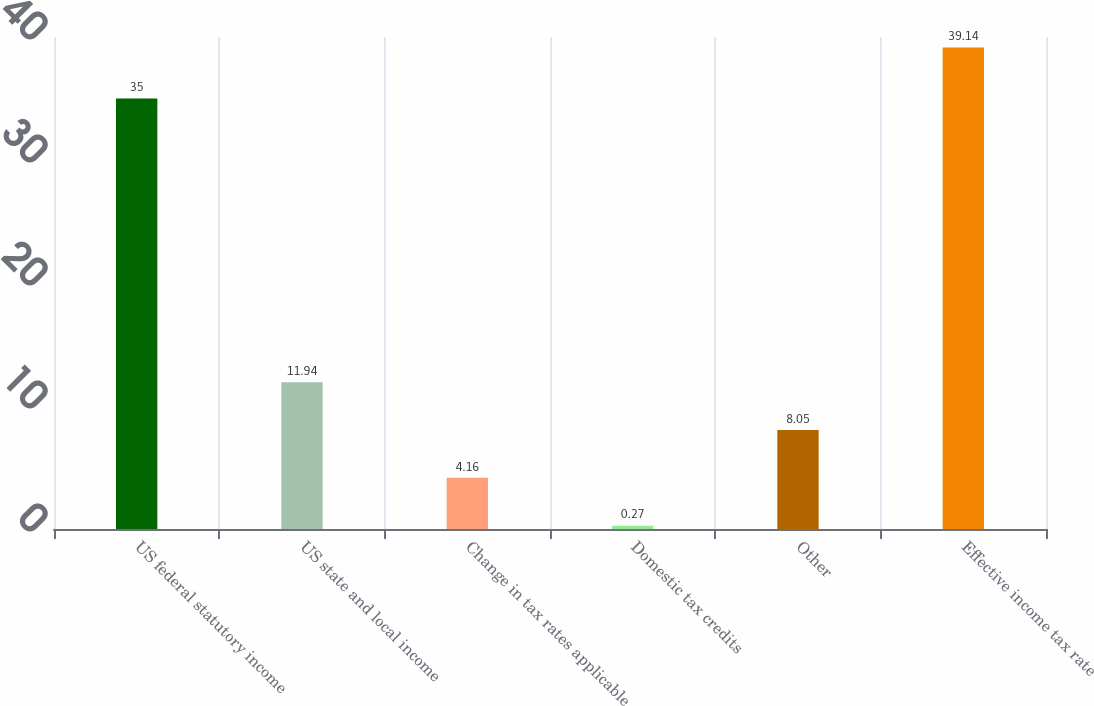<chart> <loc_0><loc_0><loc_500><loc_500><bar_chart><fcel>US federal statutory income<fcel>US state and local income<fcel>Change in tax rates applicable<fcel>Domestic tax credits<fcel>Other<fcel>Effective income tax rate<nl><fcel>35<fcel>11.94<fcel>4.16<fcel>0.27<fcel>8.05<fcel>39.14<nl></chart> 